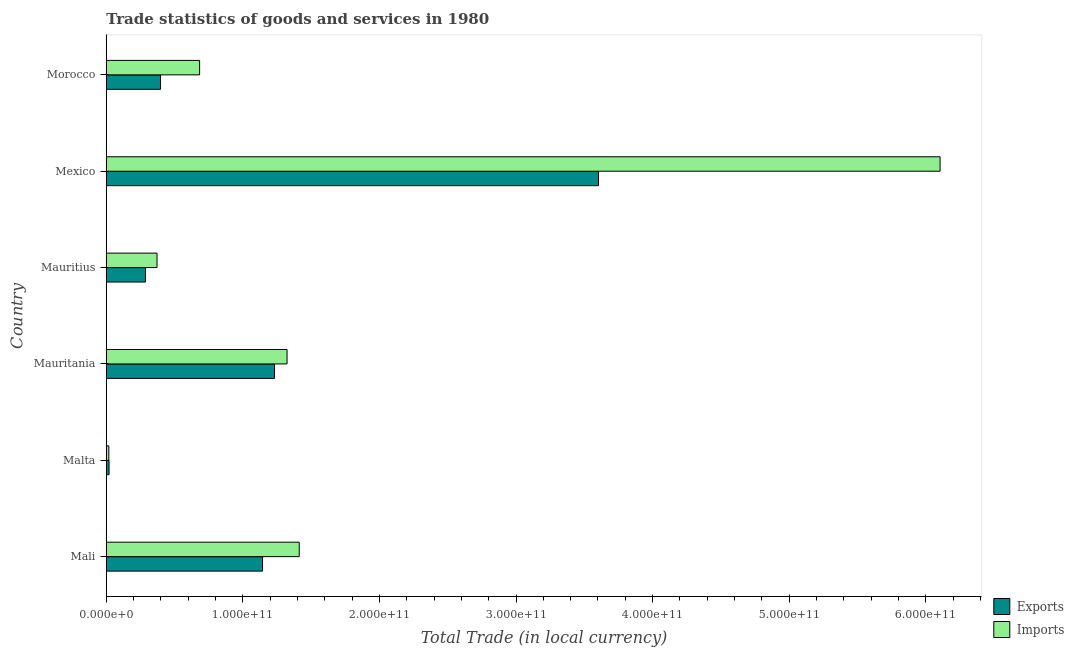How many different coloured bars are there?
Provide a short and direct response. 2. Are the number of bars per tick equal to the number of legend labels?
Your response must be concise. Yes. How many bars are there on the 6th tick from the top?
Provide a succinct answer. 2. What is the label of the 4th group of bars from the top?
Ensure brevity in your answer.  Mauritania. In how many cases, is the number of bars for a given country not equal to the number of legend labels?
Provide a succinct answer. 0. What is the export of goods and services in Mauritius?
Offer a terse response. 2.87e+1. Across all countries, what is the maximum imports of goods and services?
Make the answer very short. 6.10e+11. Across all countries, what is the minimum export of goods and services?
Give a very brief answer. 2.05e+09. In which country was the imports of goods and services minimum?
Keep it short and to the point. Malta. What is the total export of goods and services in the graph?
Offer a very short reply. 6.69e+11. What is the difference between the imports of goods and services in Mexico and that in Morocco?
Your answer should be very brief. 5.42e+11. What is the difference between the export of goods and services in Mali and the imports of goods and services in Mauritania?
Your answer should be compact. -1.80e+1. What is the average imports of goods and services per country?
Make the answer very short. 1.65e+11. What is the difference between the imports of goods and services and export of goods and services in Mauritania?
Offer a very short reply. 9.22e+09. In how many countries, is the export of goods and services greater than 120000000000 LCU?
Make the answer very short. 2. What is the ratio of the imports of goods and services in Malta to that in Mauritius?
Ensure brevity in your answer.  0.05. Is the imports of goods and services in Mauritius less than that in Mexico?
Provide a short and direct response. Yes. What is the difference between the highest and the second highest export of goods and services?
Your response must be concise. 2.37e+11. What is the difference between the highest and the lowest imports of goods and services?
Keep it short and to the point. 6.09e+11. What does the 2nd bar from the top in Malta represents?
Ensure brevity in your answer.  Exports. What does the 1st bar from the bottom in Mali represents?
Your answer should be compact. Exports. What is the difference between two consecutive major ticks on the X-axis?
Offer a very short reply. 1.00e+11. How many legend labels are there?
Make the answer very short. 2. How are the legend labels stacked?
Offer a terse response. Vertical. What is the title of the graph?
Provide a succinct answer. Trade statistics of goods and services in 1980. What is the label or title of the X-axis?
Provide a short and direct response. Total Trade (in local currency). What is the label or title of the Y-axis?
Provide a succinct answer. Country. What is the Total Trade (in local currency) in Exports in Mali?
Make the answer very short. 1.14e+11. What is the Total Trade (in local currency) of Imports in Mali?
Offer a terse response. 1.41e+11. What is the Total Trade (in local currency) of Exports in Malta?
Offer a terse response. 2.05e+09. What is the Total Trade (in local currency) in Imports in Malta?
Your answer should be compact. 1.89e+09. What is the Total Trade (in local currency) of Exports in Mauritania?
Your response must be concise. 1.23e+11. What is the Total Trade (in local currency) of Imports in Mauritania?
Ensure brevity in your answer.  1.32e+11. What is the Total Trade (in local currency) of Exports in Mauritius?
Ensure brevity in your answer.  2.87e+1. What is the Total Trade (in local currency) in Imports in Mauritius?
Make the answer very short. 3.72e+1. What is the Total Trade (in local currency) of Exports in Mexico?
Keep it short and to the point. 3.60e+11. What is the Total Trade (in local currency) of Imports in Mexico?
Your answer should be compact. 6.10e+11. What is the Total Trade (in local currency) in Exports in Morocco?
Your answer should be compact. 3.97e+1. What is the Total Trade (in local currency) in Imports in Morocco?
Your response must be concise. 6.84e+1. Across all countries, what is the maximum Total Trade (in local currency) of Exports?
Your answer should be compact. 3.60e+11. Across all countries, what is the maximum Total Trade (in local currency) in Imports?
Give a very brief answer. 6.10e+11. Across all countries, what is the minimum Total Trade (in local currency) in Exports?
Your answer should be very brief. 2.05e+09. Across all countries, what is the minimum Total Trade (in local currency) in Imports?
Keep it short and to the point. 1.89e+09. What is the total Total Trade (in local currency) of Exports in the graph?
Your response must be concise. 6.69e+11. What is the total Total Trade (in local currency) in Imports in the graph?
Keep it short and to the point. 9.92e+11. What is the difference between the Total Trade (in local currency) in Exports in Mali and that in Malta?
Ensure brevity in your answer.  1.12e+11. What is the difference between the Total Trade (in local currency) of Imports in Mali and that in Malta?
Provide a short and direct response. 1.39e+11. What is the difference between the Total Trade (in local currency) in Exports in Mali and that in Mauritania?
Provide a succinct answer. -8.74e+09. What is the difference between the Total Trade (in local currency) in Imports in Mali and that in Mauritania?
Your answer should be compact. 8.90e+09. What is the difference between the Total Trade (in local currency) in Exports in Mali and that in Mauritius?
Provide a short and direct response. 8.57e+1. What is the difference between the Total Trade (in local currency) in Imports in Mali and that in Mauritius?
Make the answer very short. 1.04e+11. What is the difference between the Total Trade (in local currency) of Exports in Mali and that in Mexico?
Ensure brevity in your answer.  -2.46e+11. What is the difference between the Total Trade (in local currency) of Imports in Mali and that in Mexico?
Your response must be concise. -4.69e+11. What is the difference between the Total Trade (in local currency) of Exports in Mali and that in Morocco?
Provide a short and direct response. 7.47e+1. What is the difference between the Total Trade (in local currency) in Imports in Mali and that in Morocco?
Make the answer very short. 7.29e+1. What is the difference between the Total Trade (in local currency) in Exports in Malta and that in Mauritania?
Provide a short and direct response. -1.21e+11. What is the difference between the Total Trade (in local currency) in Imports in Malta and that in Mauritania?
Offer a terse response. -1.31e+11. What is the difference between the Total Trade (in local currency) in Exports in Malta and that in Mauritius?
Provide a short and direct response. -2.67e+1. What is the difference between the Total Trade (in local currency) of Imports in Malta and that in Mauritius?
Make the answer very short. -3.53e+1. What is the difference between the Total Trade (in local currency) in Exports in Malta and that in Mexico?
Your response must be concise. -3.58e+11. What is the difference between the Total Trade (in local currency) of Imports in Malta and that in Mexico?
Give a very brief answer. -6.09e+11. What is the difference between the Total Trade (in local currency) of Exports in Malta and that in Morocco?
Offer a very short reply. -3.77e+1. What is the difference between the Total Trade (in local currency) of Imports in Malta and that in Morocco?
Provide a short and direct response. -6.65e+1. What is the difference between the Total Trade (in local currency) in Exports in Mauritania and that in Mauritius?
Your response must be concise. 9.45e+1. What is the difference between the Total Trade (in local currency) of Imports in Mauritania and that in Mauritius?
Provide a short and direct response. 9.52e+1. What is the difference between the Total Trade (in local currency) in Exports in Mauritania and that in Mexico?
Give a very brief answer. -2.37e+11. What is the difference between the Total Trade (in local currency) in Imports in Mauritania and that in Mexico?
Your response must be concise. -4.78e+11. What is the difference between the Total Trade (in local currency) in Exports in Mauritania and that in Morocco?
Offer a terse response. 8.34e+1. What is the difference between the Total Trade (in local currency) in Imports in Mauritania and that in Morocco?
Ensure brevity in your answer.  6.40e+1. What is the difference between the Total Trade (in local currency) of Exports in Mauritius and that in Mexico?
Make the answer very short. -3.32e+11. What is the difference between the Total Trade (in local currency) of Imports in Mauritius and that in Mexico?
Offer a very short reply. -5.73e+11. What is the difference between the Total Trade (in local currency) of Exports in Mauritius and that in Morocco?
Your answer should be very brief. -1.10e+1. What is the difference between the Total Trade (in local currency) in Imports in Mauritius and that in Morocco?
Provide a short and direct response. -3.12e+1. What is the difference between the Total Trade (in local currency) in Exports in Mexico and that in Morocco?
Give a very brief answer. 3.21e+11. What is the difference between the Total Trade (in local currency) of Imports in Mexico and that in Morocco?
Offer a terse response. 5.42e+11. What is the difference between the Total Trade (in local currency) of Exports in Mali and the Total Trade (in local currency) of Imports in Malta?
Your response must be concise. 1.13e+11. What is the difference between the Total Trade (in local currency) in Exports in Mali and the Total Trade (in local currency) in Imports in Mauritania?
Ensure brevity in your answer.  -1.80e+1. What is the difference between the Total Trade (in local currency) of Exports in Mali and the Total Trade (in local currency) of Imports in Mauritius?
Ensure brevity in your answer.  7.72e+1. What is the difference between the Total Trade (in local currency) in Exports in Mali and the Total Trade (in local currency) in Imports in Mexico?
Provide a succinct answer. -4.96e+11. What is the difference between the Total Trade (in local currency) in Exports in Mali and the Total Trade (in local currency) in Imports in Morocco?
Offer a terse response. 4.61e+1. What is the difference between the Total Trade (in local currency) in Exports in Malta and the Total Trade (in local currency) in Imports in Mauritania?
Keep it short and to the point. -1.30e+11. What is the difference between the Total Trade (in local currency) in Exports in Malta and the Total Trade (in local currency) in Imports in Mauritius?
Offer a very short reply. -3.51e+1. What is the difference between the Total Trade (in local currency) in Exports in Malta and the Total Trade (in local currency) in Imports in Mexico?
Keep it short and to the point. -6.08e+11. What is the difference between the Total Trade (in local currency) in Exports in Malta and the Total Trade (in local currency) in Imports in Morocco?
Your answer should be compact. -6.63e+1. What is the difference between the Total Trade (in local currency) in Exports in Mauritania and the Total Trade (in local currency) in Imports in Mauritius?
Ensure brevity in your answer.  8.60e+1. What is the difference between the Total Trade (in local currency) of Exports in Mauritania and the Total Trade (in local currency) of Imports in Mexico?
Ensure brevity in your answer.  -4.87e+11. What is the difference between the Total Trade (in local currency) in Exports in Mauritania and the Total Trade (in local currency) in Imports in Morocco?
Your response must be concise. 5.48e+1. What is the difference between the Total Trade (in local currency) of Exports in Mauritius and the Total Trade (in local currency) of Imports in Mexico?
Provide a short and direct response. -5.82e+11. What is the difference between the Total Trade (in local currency) in Exports in Mauritius and the Total Trade (in local currency) in Imports in Morocco?
Offer a very short reply. -3.96e+1. What is the difference between the Total Trade (in local currency) in Exports in Mexico and the Total Trade (in local currency) in Imports in Morocco?
Offer a terse response. 2.92e+11. What is the average Total Trade (in local currency) of Exports per country?
Make the answer very short. 1.11e+11. What is the average Total Trade (in local currency) of Imports per country?
Your answer should be compact. 1.65e+11. What is the difference between the Total Trade (in local currency) in Exports and Total Trade (in local currency) in Imports in Mali?
Make the answer very short. -2.69e+1. What is the difference between the Total Trade (in local currency) in Exports and Total Trade (in local currency) in Imports in Malta?
Your answer should be very brief. 1.64e+08. What is the difference between the Total Trade (in local currency) in Exports and Total Trade (in local currency) in Imports in Mauritania?
Provide a short and direct response. -9.22e+09. What is the difference between the Total Trade (in local currency) in Exports and Total Trade (in local currency) in Imports in Mauritius?
Offer a terse response. -8.47e+09. What is the difference between the Total Trade (in local currency) of Exports and Total Trade (in local currency) of Imports in Mexico?
Your answer should be very brief. -2.50e+11. What is the difference between the Total Trade (in local currency) of Exports and Total Trade (in local currency) of Imports in Morocco?
Give a very brief answer. -2.86e+1. What is the ratio of the Total Trade (in local currency) in Exports in Mali to that in Malta?
Ensure brevity in your answer.  55.85. What is the ratio of the Total Trade (in local currency) of Imports in Mali to that in Malta?
Provide a short and direct response. 74.94. What is the ratio of the Total Trade (in local currency) of Exports in Mali to that in Mauritania?
Your answer should be compact. 0.93. What is the ratio of the Total Trade (in local currency) in Imports in Mali to that in Mauritania?
Offer a very short reply. 1.07. What is the ratio of the Total Trade (in local currency) in Exports in Mali to that in Mauritius?
Offer a very short reply. 3.98. What is the ratio of the Total Trade (in local currency) in Imports in Mali to that in Mauritius?
Your answer should be very brief. 3.8. What is the ratio of the Total Trade (in local currency) of Exports in Mali to that in Mexico?
Give a very brief answer. 0.32. What is the ratio of the Total Trade (in local currency) in Imports in Mali to that in Mexico?
Provide a short and direct response. 0.23. What is the ratio of the Total Trade (in local currency) of Exports in Mali to that in Morocco?
Ensure brevity in your answer.  2.88. What is the ratio of the Total Trade (in local currency) in Imports in Mali to that in Morocco?
Your answer should be very brief. 2.07. What is the ratio of the Total Trade (in local currency) in Exports in Malta to that in Mauritania?
Offer a terse response. 0.02. What is the ratio of the Total Trade (in local currency) of Imports in Malta to that in Mauritania?
Your answer should be compact. 0.01. What is the ratio of the Total Trade (in local currency) in Exports in Malta to that in Mauritius?
Make the answer very short. 0.07. What is the ratio of the Total Trade (in local currency) of Imports in Malta to that in Mauritius?
Keep it short and to the point. 0.05. What is the ratio of the Total Trade (in local currency) in Exports in Malta to that in Mexico?
Provide a short and direct response. 0.01. What is the ratio of the Total Trade (in local currency) of Imports in Malta to that in Mexico?
Provide a short and direct response. 0. What is the ratio of the Total Trade (in local currency) of Exports in Malta to that in Morocco?
Ensure brevity in your answer.  0.05. What is the ratio of the Total Trade (in local currency) in Imports in Malta to that in Morocco?
Offer a terse response. 0.03. What is the ratio of the Total Trade (in local currency) of Exports in Mauritania to that in Mauritius?
Make the answer very short. 4.29. What is the ratio of the Total Trade (in local currency) in Imports in Mauritania to that in Mauritius?
Your answer should be compact. 3.56. What is the ratio of the Total Trade (in local currency) in Exports in Mauritania to that in Mexico?
Provide a short and direct response. 0.34. What is the ratio of the Total Trade (in local currency) in Imports in Mauritania to that in Mexico?
Your answer should be compact. 0.22. What is the ratio of the Total Trade (in local currency) in Exports in Mauritania to that in Morocco?
Make the answer very short. 3.1. What is the ratio of the Total Trade (in local currency) in Imports in Mauritania to that in Morocco?
Give a very brief answer. 1.94. What is the ratio of the Total Trade (in local currency) of Exports in Mauritius to that in Mexico?
Offer a terse response. 0.08. What is the ratio of the Total Trade (in local currency) of Imports in Mauritius to that in Mexico?
Your answer should be compact. 0.06. What is the ratio of the Total Trade (in local currency) of Exports in Mauritius to that in Morocco?
Provide a short and direct response. 0.72. What is the ratio of the Total Trade (in local currency) of Imports in Mauritius to that in Morocco?
Give a very brief answer. 0.54. What is the ratio of the Total Trade (in local currency) in Exports in Mexico to that in Morocco?
Ensure brevity in your answer.  9.07. What is the ratio of the Total Trade (in local currency) of Imports in Mexico to that in Morocco?
Offer a terse response. 8.93. What is the difference between the highest and the second highest Total Trade (in local currency) in Exports?
Offer a terse response. 2.37e+11. What is the difference between the highest and the second highest Total Trade (in local currency) in Imports?
Your answer should be very brief. 4.69e+11. What is the difference between the highest and the lowest Total Trade (in local currency) of Exports?
Give a very brief answer. 3.58e+11. What is the difference between the highest and the lowest Total Trade (in local currency) in Imports?
Offer a terse response. 6.09e+11. 